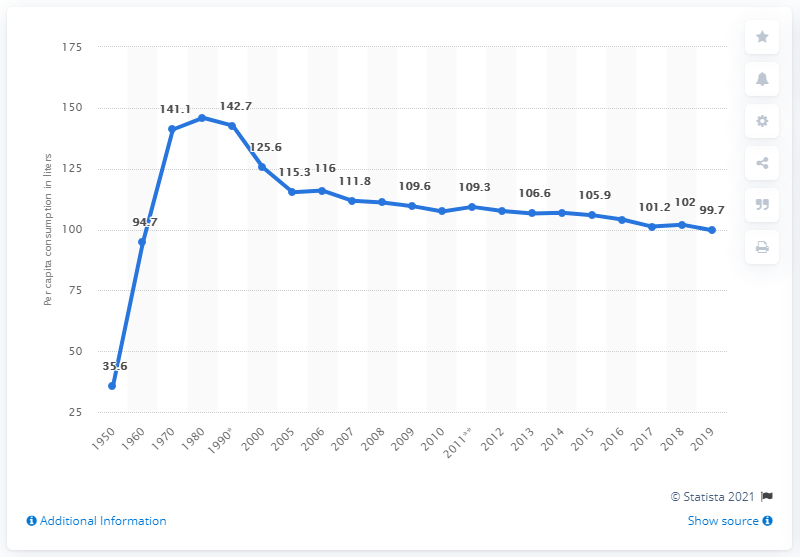List a handful of essential elements in this visual. According to the latest data available in 2019, the per capita consumption of beer in Germany was approximately 99.7 liters per person. According to the data, the total per capita consumption of beer in Germany from 2018 to 2019 was 201.7 liters per person. 